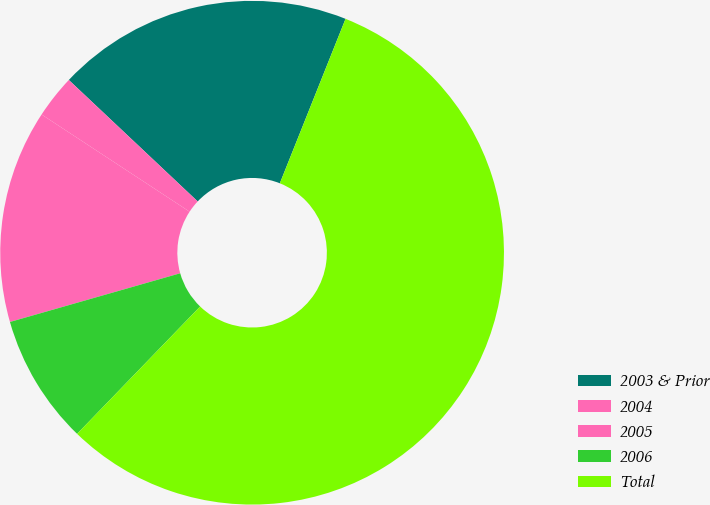Convert chart to OTSL. <chart><loc_0><loc_0><loc_500><loc_500><pie_chart><fcel>2003 & Prior<fcel>2004<fcel>2005<fcel>2006<fcel>Total<nl><fcel>19.02%<fcel>2.78%<fcel>13.68%<fcel>8.34%<fcel>56.17%<nl></chart> 